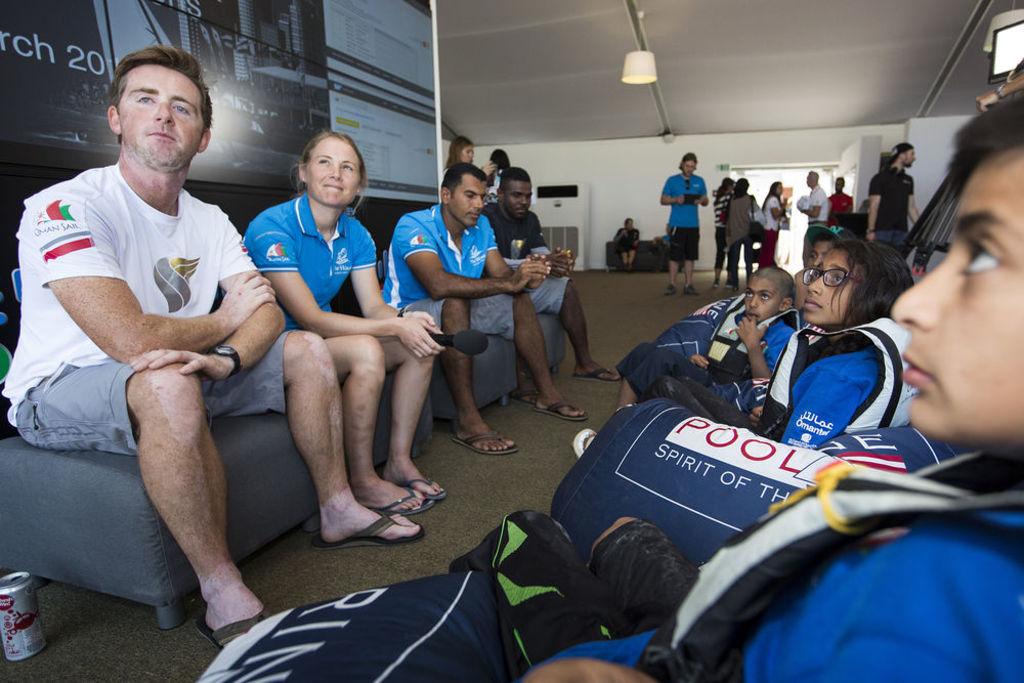To which sailing team does the man in the white shirt belong?
Provide a succinct answer. Oman sail. 